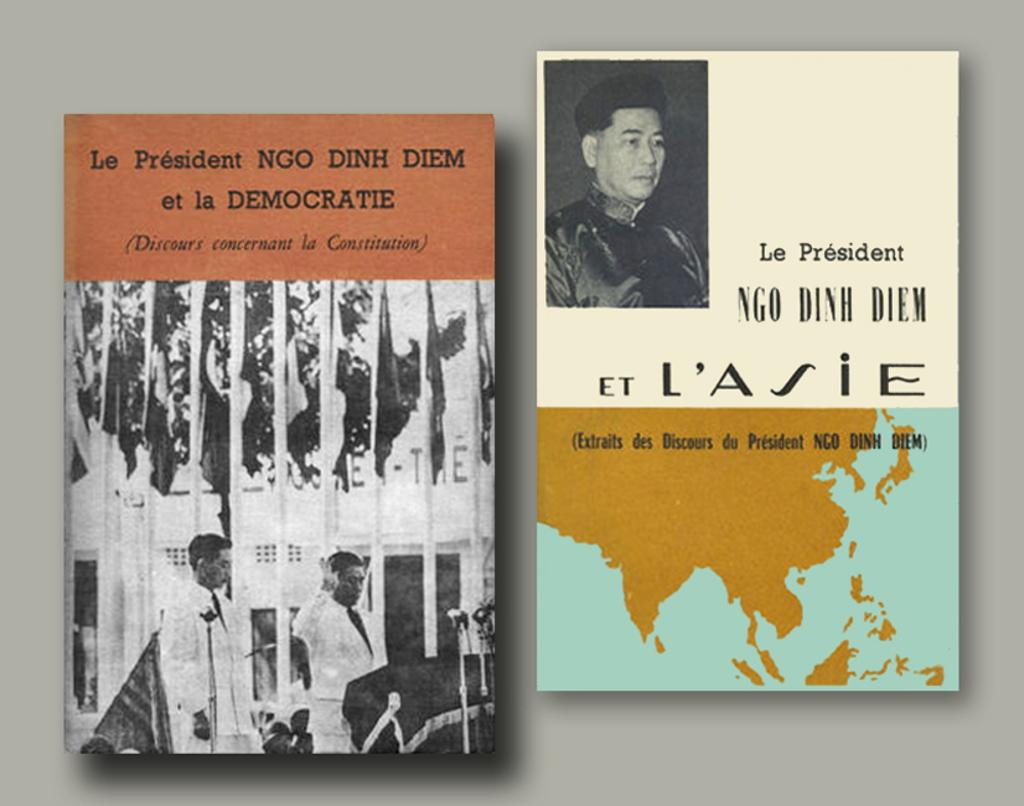What objects can be seen in the image? There are books in the image. Where are the books located? The books are placed on a surface. What is the fifth industry represented in the image? There is no mention of industries in the image, as it only features books placed on a surface. 